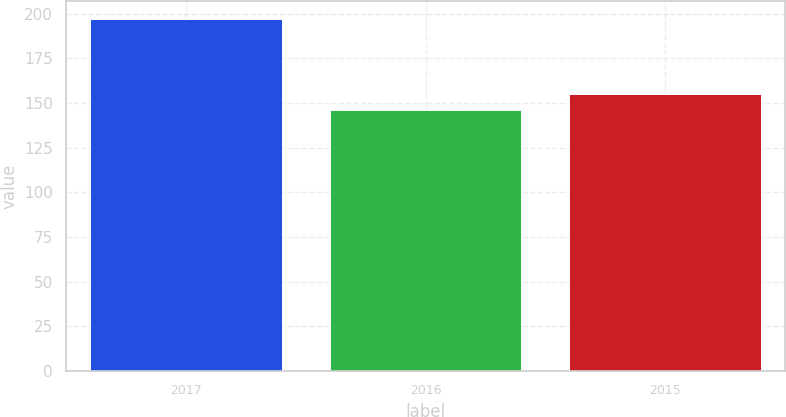Convert chart. <chart><loc_0><loc_0><loc_500><loc_500><bar_chart><fcel>2017<fcel>2016<fcel>2015<nl><fcel>197<fcel>146<fcel>155.1<nl></chart> 